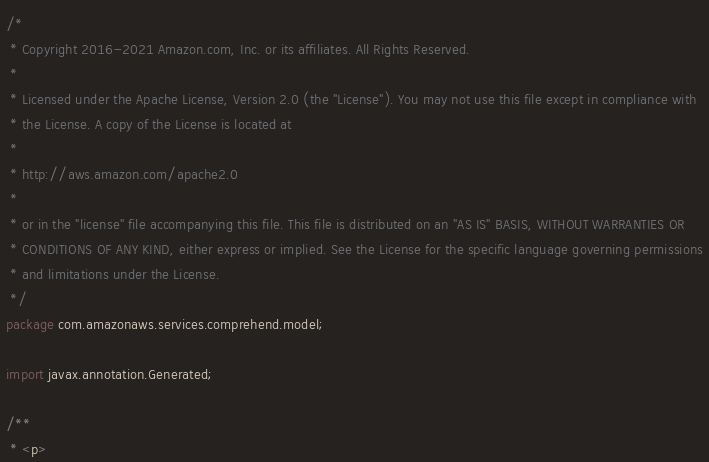Convert code to text. <code><loc_0><loc_0><loc_500><loc_500><_Java_>/*
 * Copyright 2016-2021 Amazon.com, Inc. or its affiliates. All Rights Reserved.
 * 
 * Licensed under the Apache License, Version 2.0 (the "License"). You may not use this file except in compliance with
 * the License. A copy of the License is located at
 * 
 * http://aws.amazon.com/apache2.0
 * 
 * or in the "license" file accompanying this file. This file is distributed on an "AS IS" BASIS, WITHOUT WARRANTIES OR
 * CONDITIONS OF ANY KIND, either express or implied. See the License for the specific language governing permissions
 * and limitations under the License.
 */
package com.amazonaws.services.comprehend.model;

import javax.annotation.Generated;

/**
 * <p></code> 